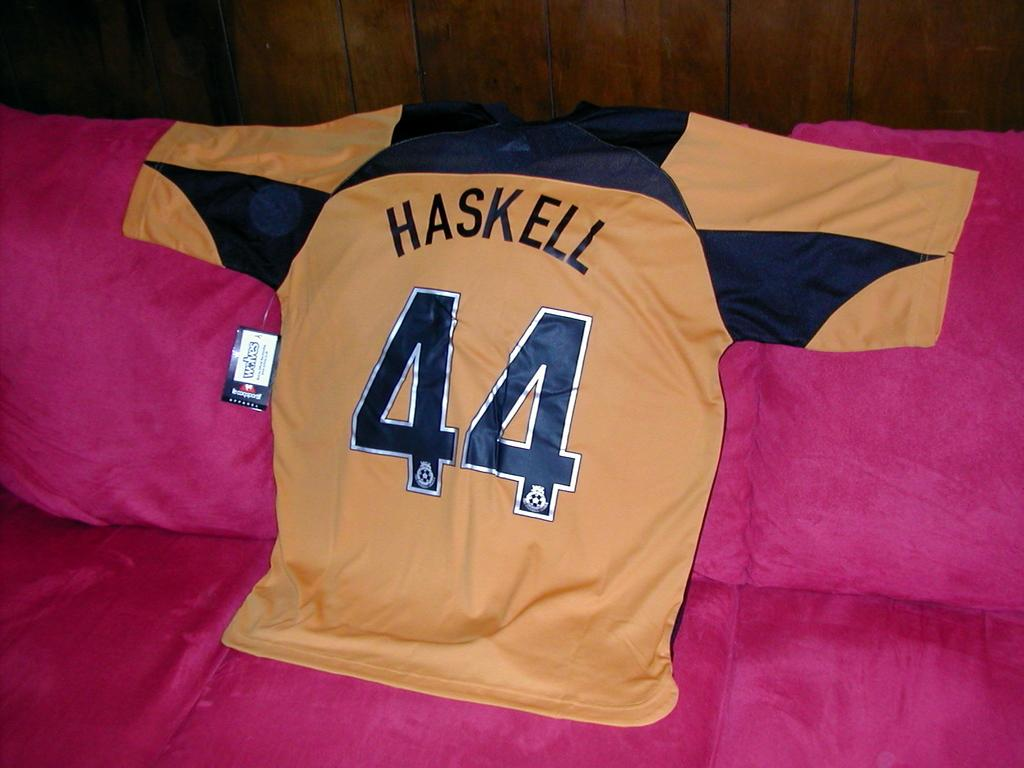Provide a one-sentence caption for the provided image. The young man brought his favorite "Haskell" jersey for the hockey game. 